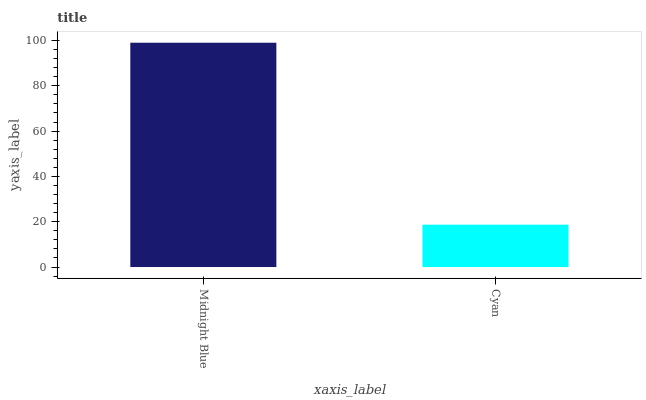Is Cyan the minimum?
Answer yes or no. Yes. Is Midnight Blue the maximum?
Answer yes or no. Yes. Is Cyan the maximum?
Answer yes or no. No. Is Midnight Blue greater than Cyan?
Answer yes or no. Yes. Is Cyan less than Midnight Blue?
Answer yes or no. Yes. Is Cyan greater than Midnight Blue?
Answer yes or no. No. Is Midnight Blue less than Cyan?
Answer yes or no. No. Is Midnight Blue the high median?
Answer yes or no. Yes. Is Cyan the low median?
Answer yes or no. Yes. Is Cyan the high median?
Answer yes or no. No. Is Midnight Blue the low median?
Answer yes or no. No. 